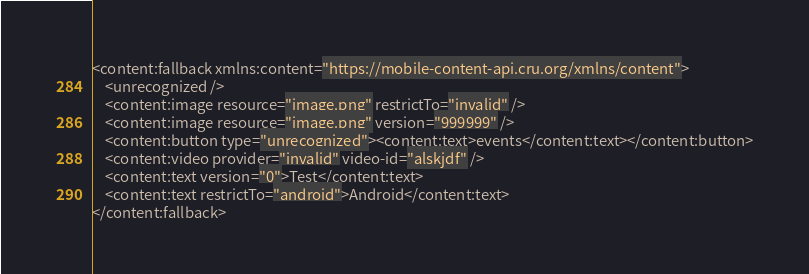<code> <loc_0><loc_0><loc_500><loc_500><_XML_><content:fallback xmlns:content="https://mobile-content-api.cru.org/xmlns/content">
    <unrecognized />
    <content:image resource="image.png" restrictTo="invalid" />
    <content:image resource="image.png" version="999999" />
    <content:button type="unrecognized"><content:text>events</content:text></content:button>
    <content:video provider="invalid" video-id="alskjdf" />
    <content:text version="0">Test</content:text>
    <content:text restrictTo="android">Android</content:text>
</content:fallback>
</code> 